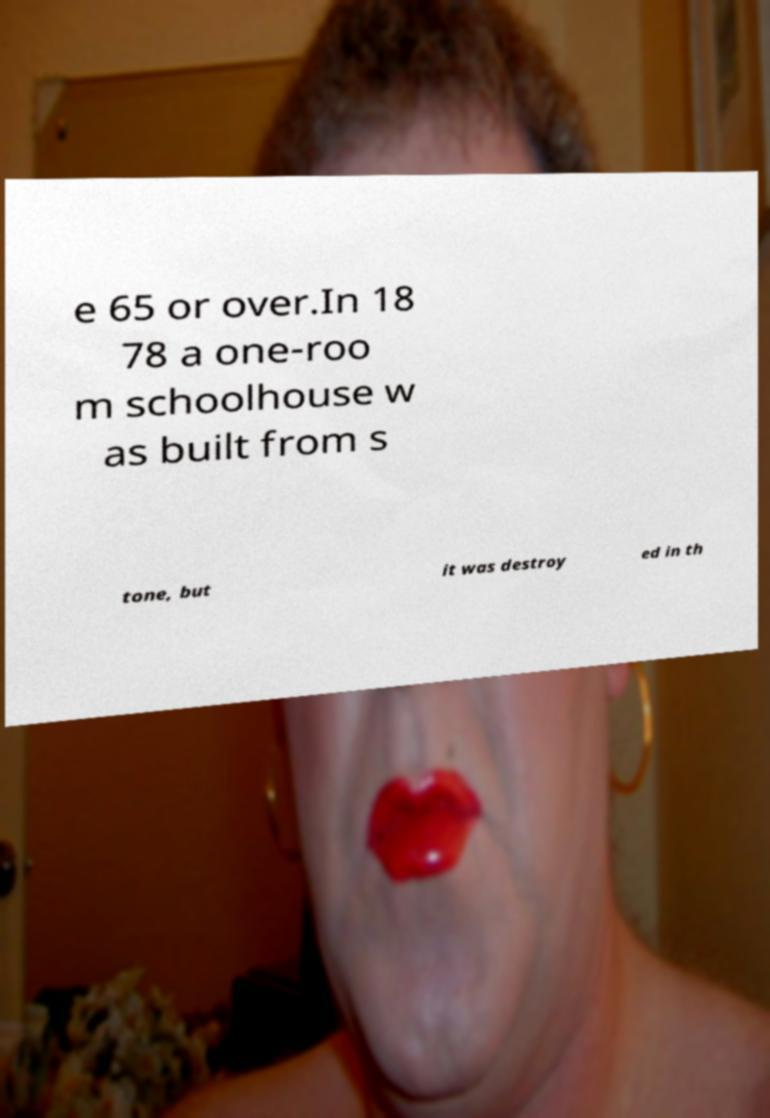There's text embedded in this image that I need extracted. Can you transcribe it verbatim? e 65 or over.In 18 78 a one-roo m schoolhouse w as built from s tone, but it was destroy ed in th 